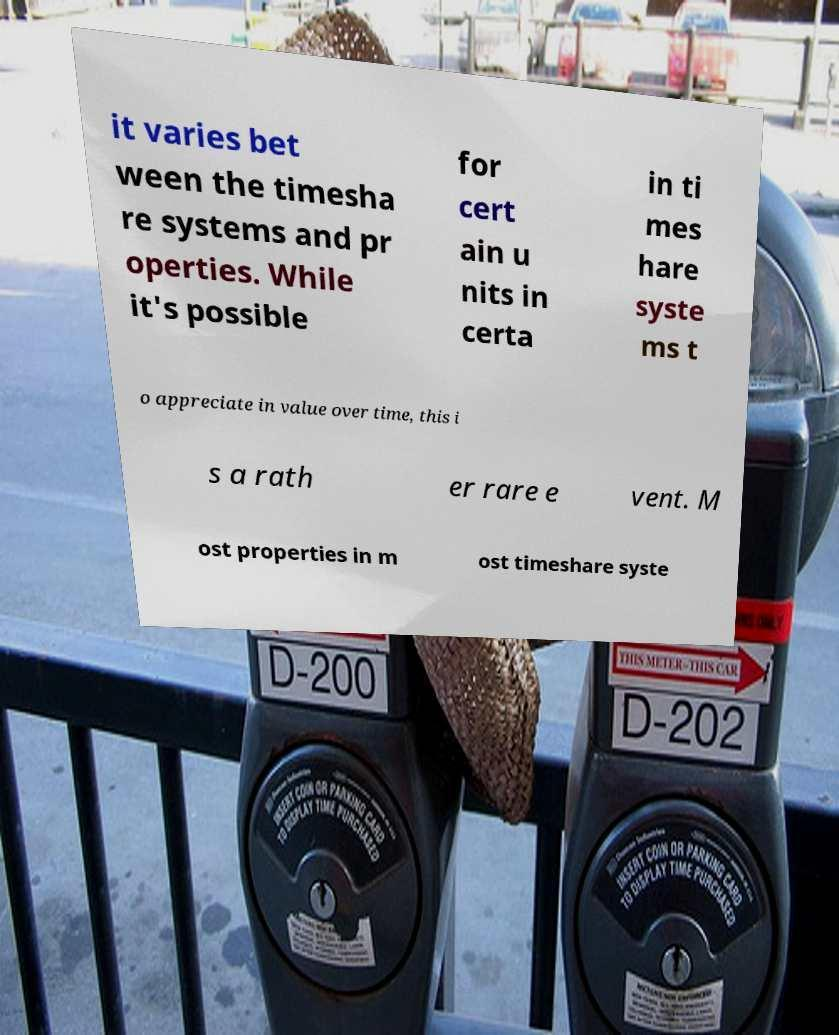What messages or text are displayed in this image? I need them in a readable, typed format. it varies bet ween the timesha re systems and pr operties. While it's possible for cert ain u nits in certa in ti mes hare syste ms t o appreciate in value over time, this i s a rath er rare e vent. M ost properties in m ost timeshare syste 